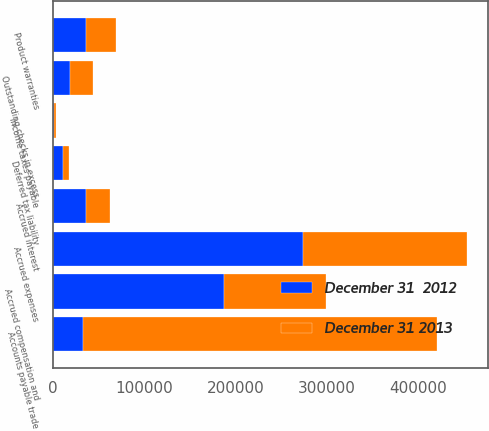Convert chart. <chart><loc_0><loc_0><loc_500><loc_500><stacked_bar_chart><ecel><fcel>Outstanding checks in excess<fcel>Accounts payable trade<fcel>Accrued expenses<fcel>Product warranties<fcel>Accrued interest<fcel>Deferred tax liability<fcel>Income taxes payable<fcel>Accrued compensation and<nl><fcel>December 31  2012<fcel>18012<fcel>32930<fcel>273230<fcel>35818<fcel>35618<fcel>11235<fcel>1095<fcel>186853<nl><fcel>December 31 2013<fcel>25480<fcel>387871<fcel>180039<fcel>32930<fcel>26843<fcel>6309<fcel>2074<fcel>111890<nl></chart> 